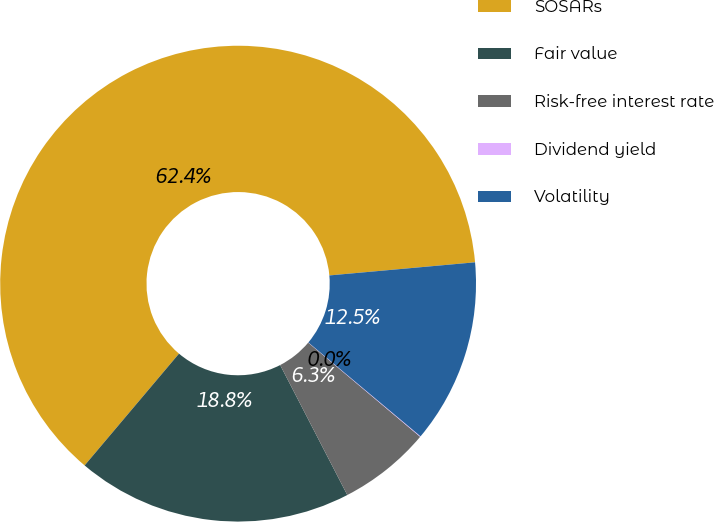Convert chart. <chart><loc_0><loc_0><loc_500><loc_500><pie_chart><fcel>SOSARs<fcel>Fair value<fcel>Risk-free interest rate<fcel>Dividend yield<fcel>Volatility<nl><fcel>62.41%<fcel>18.75%<fcel>6.28%<fcel>0.04%<fcel>12.52%<nl></chart> 